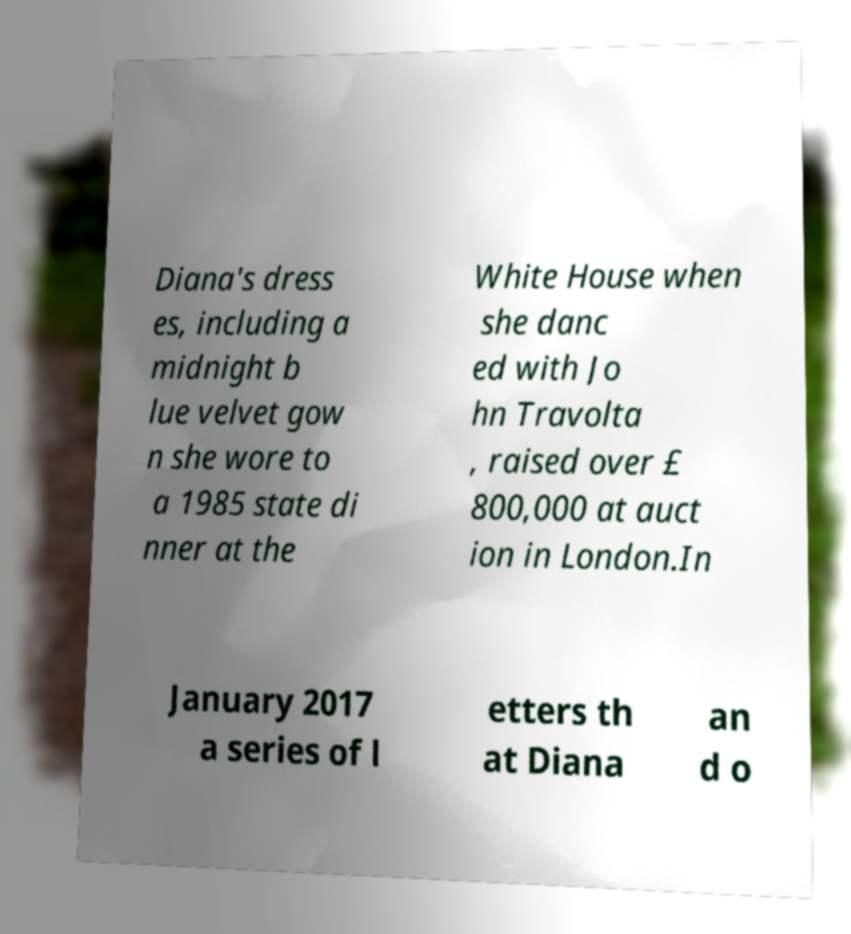For documentation purposes, I need the text within this image transcribed. Could you provide that? Diana's dress es, including a midnight b lue velvet gow n she wore to a 1985 state di nner at the White House when she danc ed with Jo hn Travolta , raised over £ 800,000 at auct ion in London.In January 2017 a series of l etters th at Diana an d o 